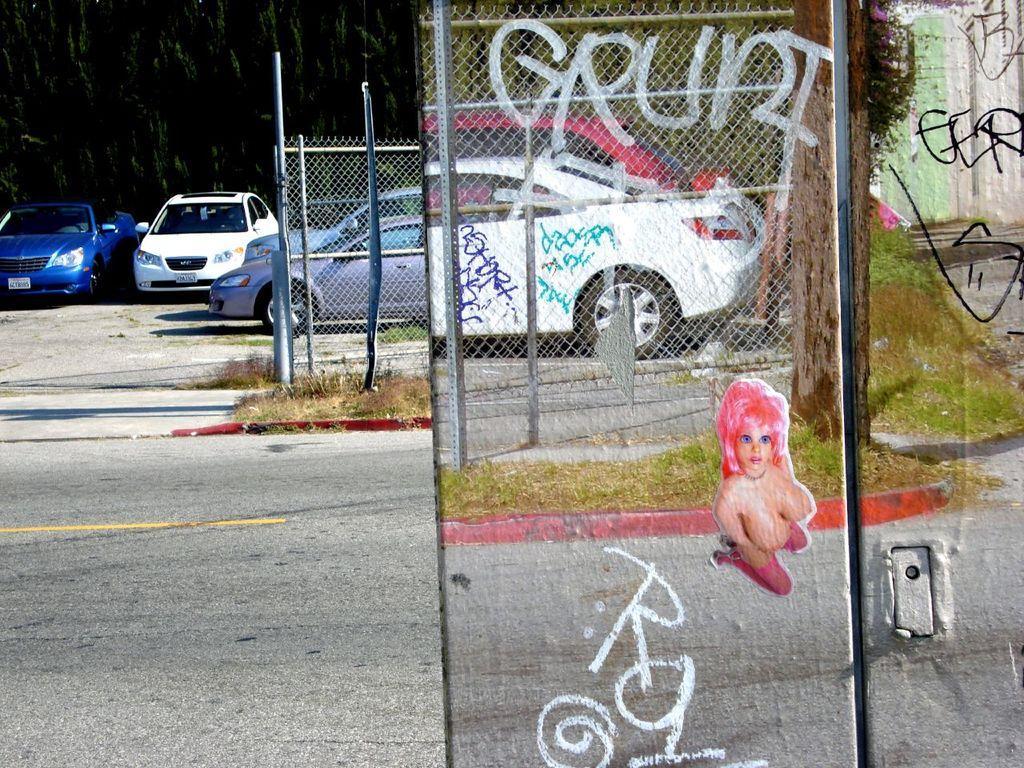Describe this image in one or two sentences. This picture is clicked outside. On the right we can see the picture of a woman and we can see the text and we can see the green grass, tree, mesh, metal rods. In the center we can see the group of cars seems to be parked on the ground and we can see the metal rods and some other objects and this picture seems to be an edited image. 